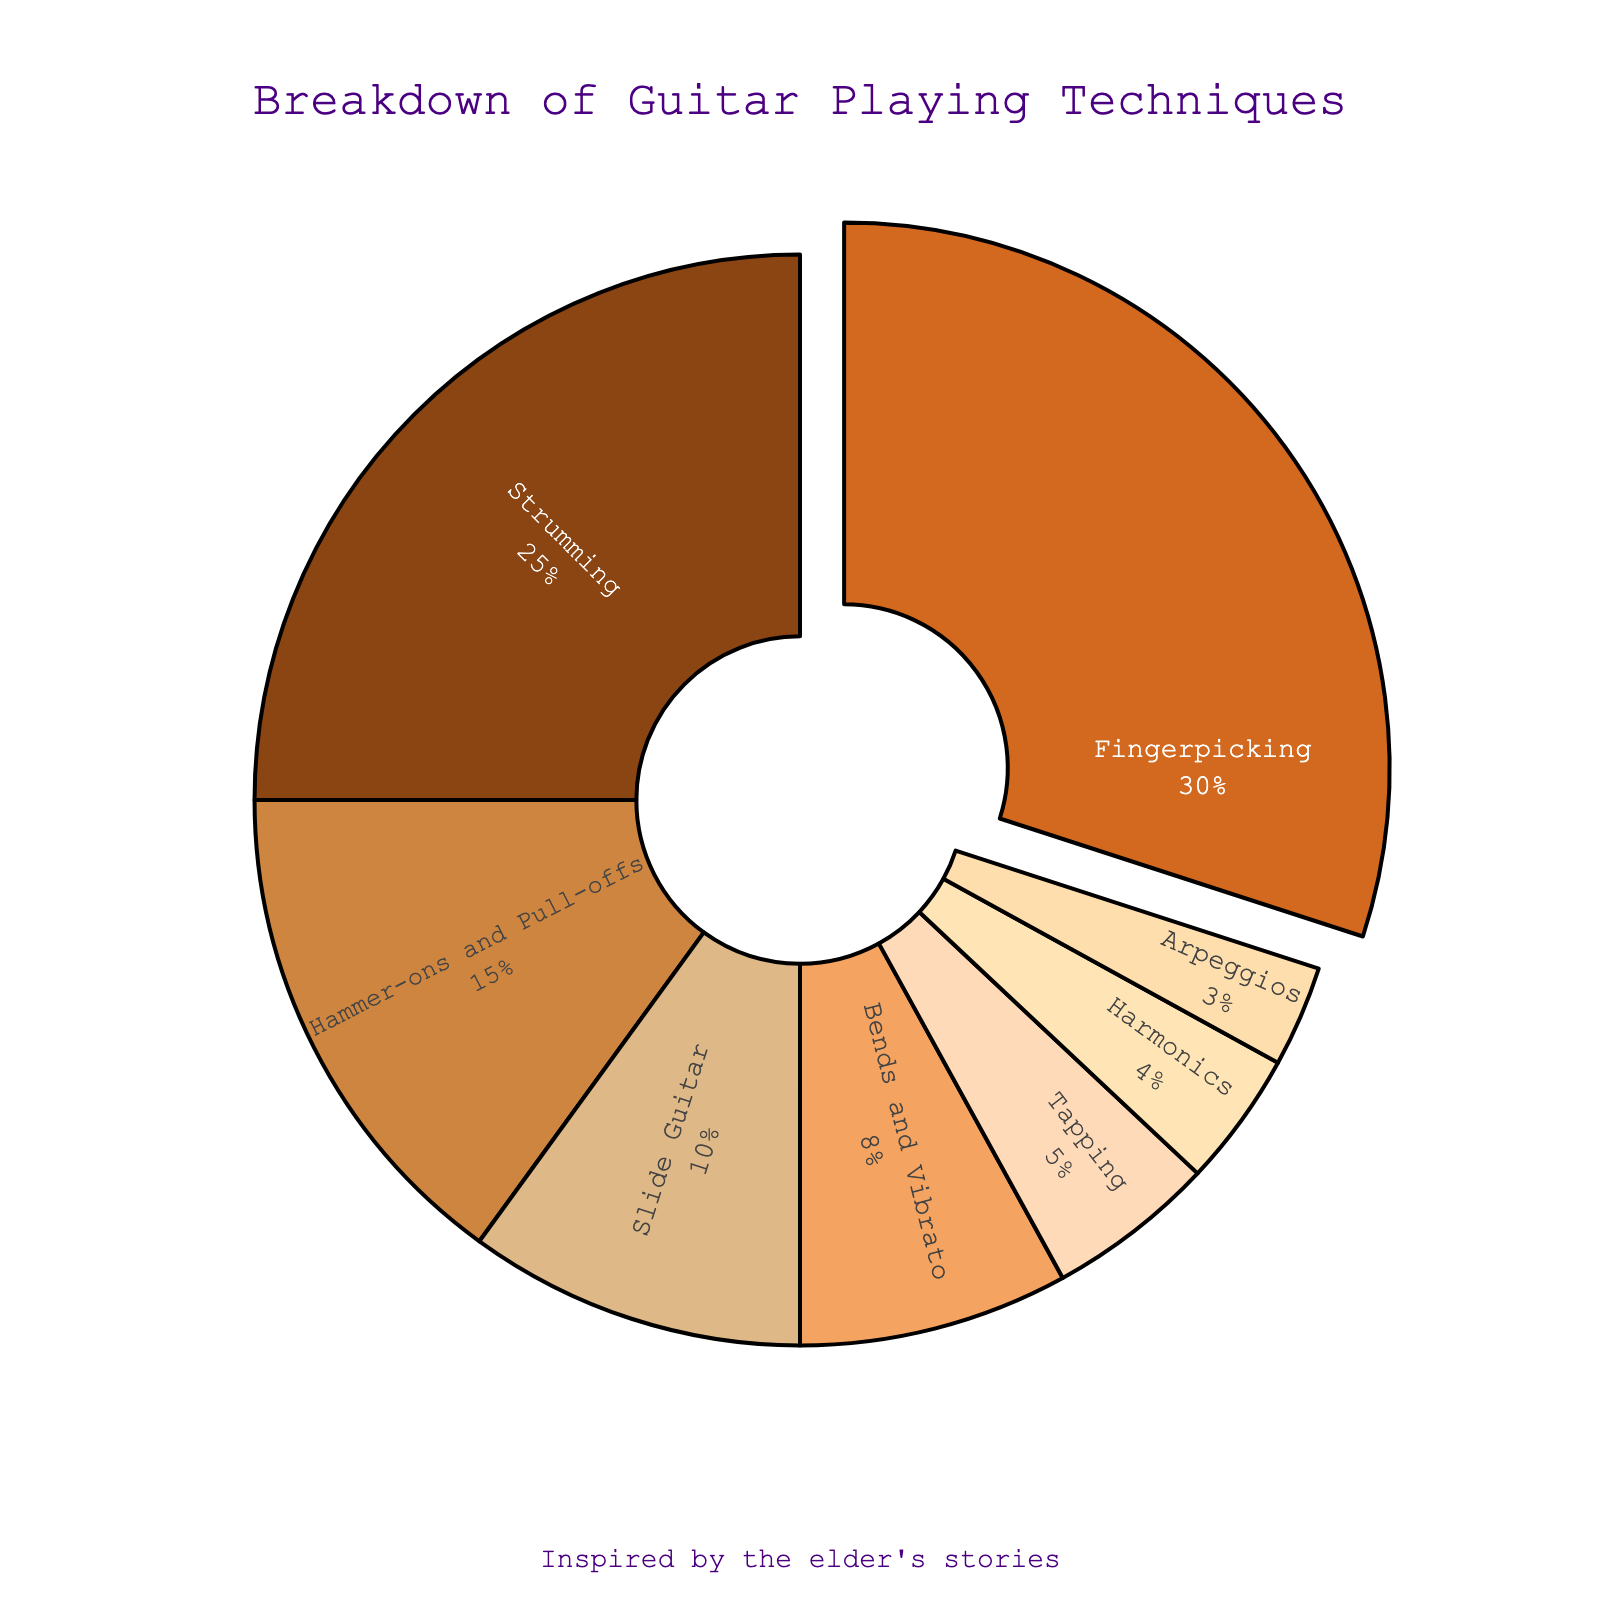What are the three most common guitar playing techniques used in the performances? The three largest sections in the pie chart represent the most common techniques. The first is Fingerpicking (30%), the second is Strumming (25%), and the third is Hammer-ons and Pull-offs (15%).
Answer: Fingerpicking, Strumming, Hammer-ons and Pull-offs Which technique has the smallest percentage, and what is it? The smallest segment in the pie chart is for Arpeggios, which has a 3% share.
Answer: Arpeggios How much larger in percentage is Fingerpicking compared to Bends and Vibrato? Fingerpicking has a percentage of 30%, while Bends and Vibrato are at 8%. The difference is calculated as 30% - 8% = 22%.
Answer: 22% If you combine the percentages of Slide Guitar and Tapping, what would their combined percentage be? The percentages for Slide Guitar and Tapping are 10% and 5%, respectively. Adding these together gives 10% + 5% = 15%.
Answer: 15% What is the total percentage for techniques that have less than 10% each? The techniques with less than 10% are Slide Guitar (10%), Bends and Vibrato (8%), Tapping (5%), Harmonics (4%), and Arpeggios (3%). Their combined total is 10% + 8% + 5% + 4% + 3% = 30%.
Answer: 30% Which technique is represented by the darkest segment in the pie chart? The darkest segment in the pie chart corresponds to the largest section, which is Fingerpicking with 30%.
Answer: Fingerpicking What colors are used to distinguish the Fingerpicking and Strumming segments in the pie chart? Fingerpicking and Strumming occupy the first and second segments, being represented with the colors closest to the beginning of the specified color sequence: dark brown and a slightly lighter brown, respectively.
Answer: Dark Brown and Light Brown Which technique is placed in the pie chart at the position of greatest visual prominence due to being 'pulled out' from the rest? The Fingerpicking technique is visually pulled out from the rest of the segments in the pie chart, indicating its prominence.
Answer: Fingerpicking How much more prevalent is Strumming compared to Tapping? Strumming has a percentage of 25%, while Tapping has a percentage of 5%. The difference is calculated as 25% - 5% = 20%.
Answer: 20% 